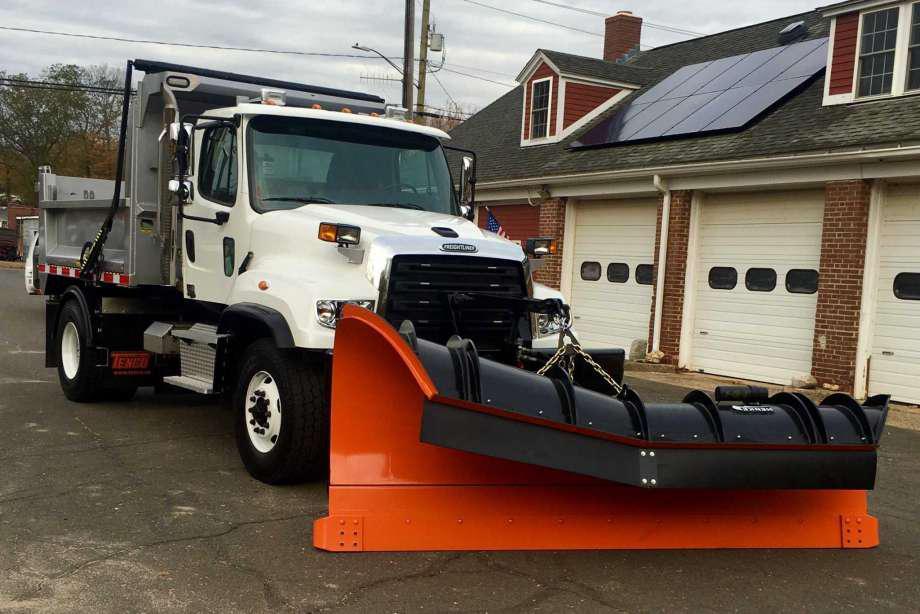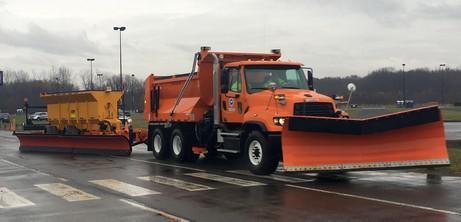The first image is the image on the left, the second image is the image on the right. Examine the images to the left and right. Is the description "Each image shows a truck with a red-orange front plow angled facing rightward, and one image features an orange truck pulling a plow." accurate? Answer yes or no. Yes. 